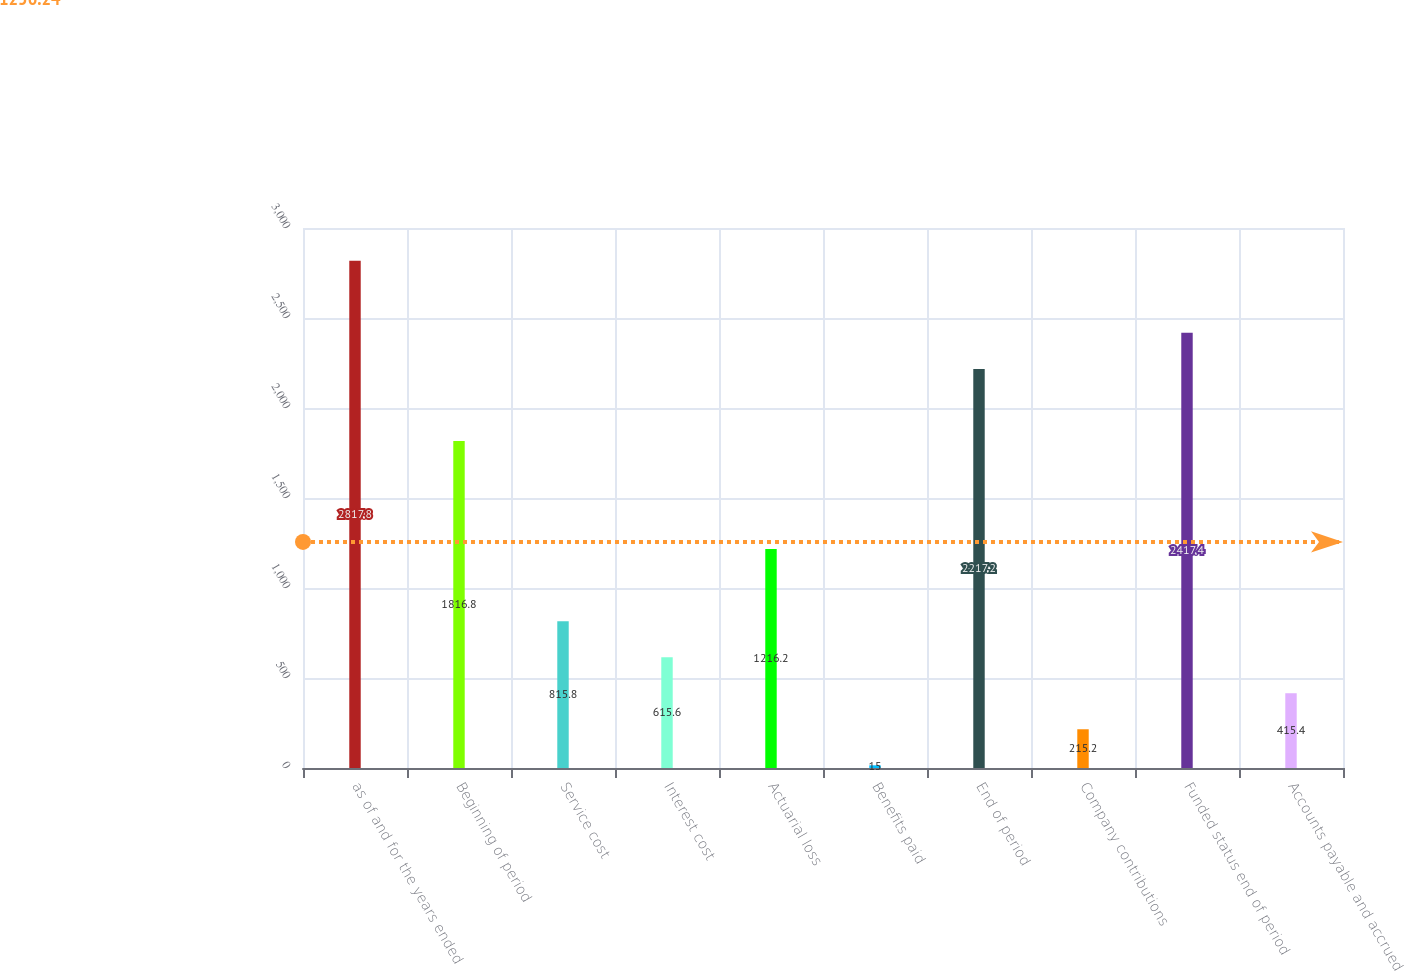Convert chart to OTSL. <chart><loc_0><loc_0><loc_500><loc_500><bar_chart><fcel>as of and for the years ended<fcel>Beginning of period<fcel>Service cost<fcel>Interest cost<fcel>Actuarial loss<fcel>Benefits paid<fcel>End of period<fcel>Company contributions<fcel>Funded status end of period<fcel>Accounts payable and accrued<nl><fcel>2817.8<fcel>1816.8<fcel>815.8<fcel>615.6<fcel>1216.2<fcel>15<fcel>2217.2<fcel>215.2<fcel>2417.4<fcel>415.4<nl></chart> 